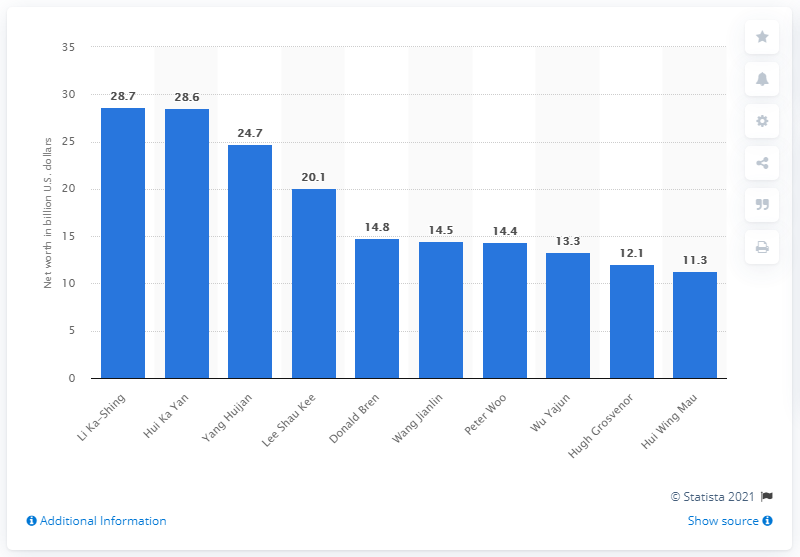List a handful of essential elements in this visual. The owner of the Irvine Company is Donald Bren. 